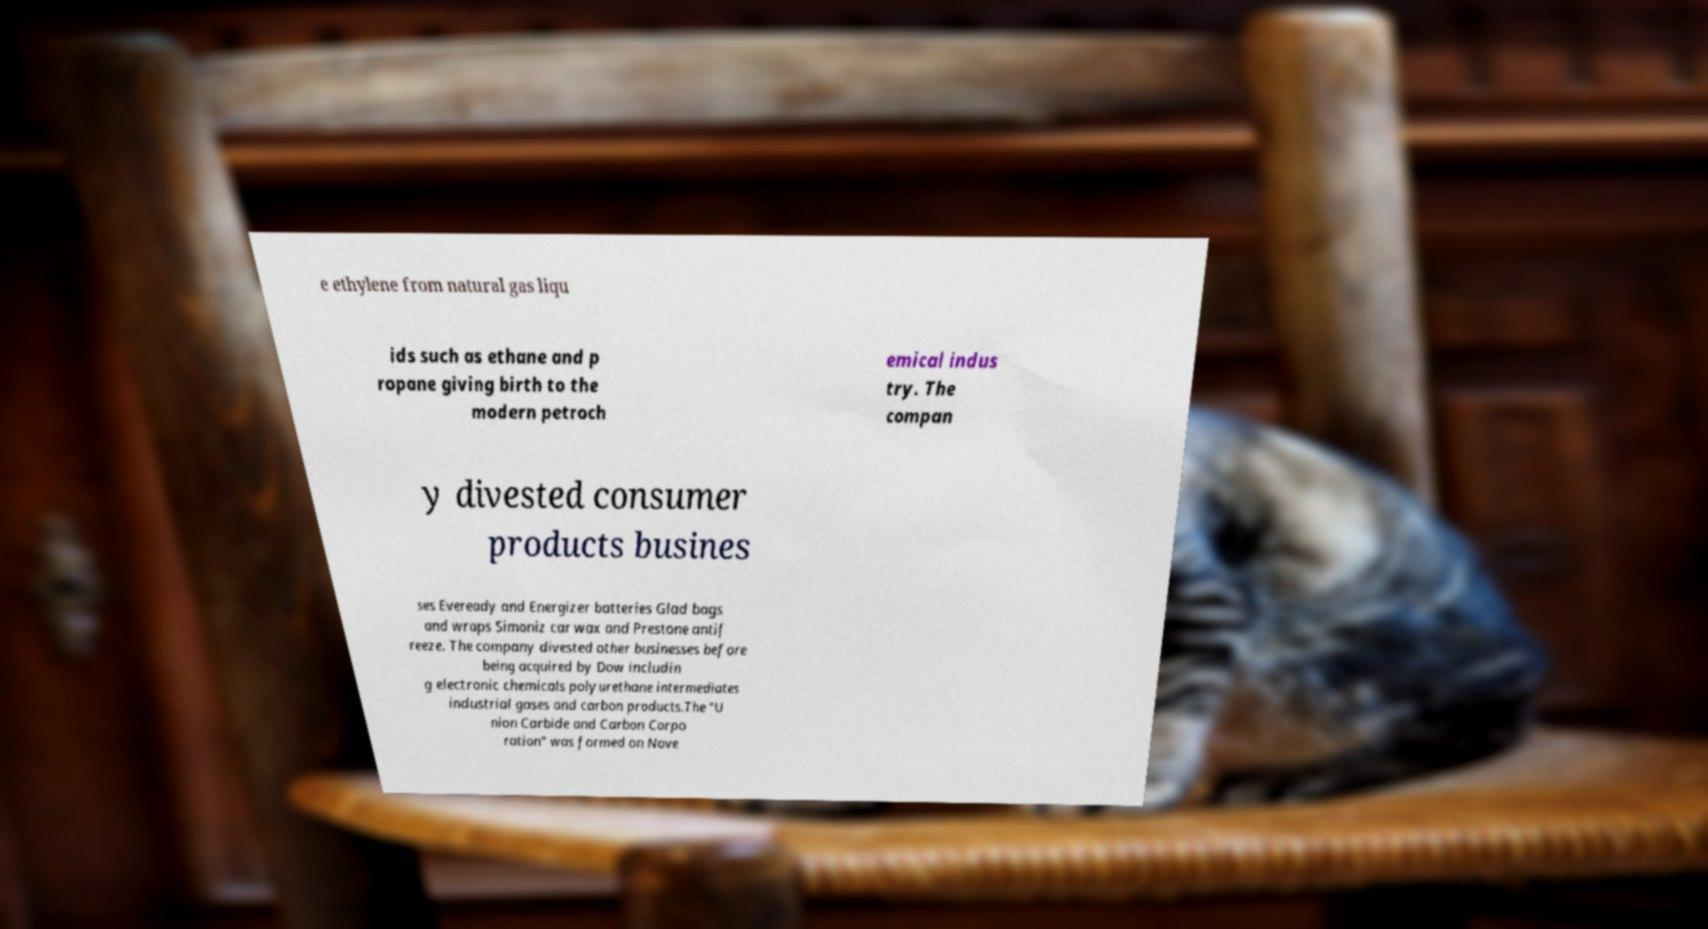Can you read and provide the text displayed in the image?This photo seems to have some interesting text. Can you extract and type it out for me? e ethylene from natural gas liqu ids such as ethane and p ropane giving birth to the modern petroch emical indus try. The compan y divested consumer products busines ses Eveready and Energizer batteries Glad bags and wraps Simoniz car wax and Prestone antif reeze. The company divested other businesses before being acquired by Dow includin g electronic chemicals polyurethane intermediates industrial gases and carbon products.The "U nion Carbide and Carbon Corpo ration" was formed on Nove 